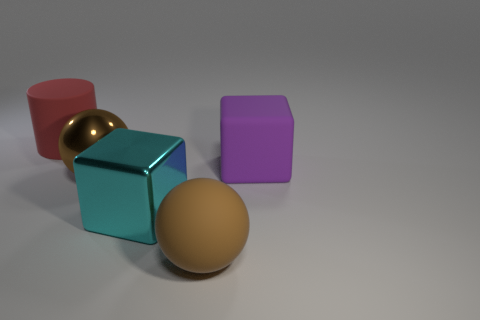Subtract all cyan blocks. How many blocks are left? 1 Add 1 matte cylinders. How many objects exist? 6 Subtract all blocks. How many objects are left? 3 Add 4 large brown metal objects. How many large brown metal objects are left? 5 Add 1 cyan spheres. How many cyan spheres exist? 1 Subtract 0 gray cylinders. How many objects are left? 5 Subtract 1 blocks. How many blocks are left? 1 Subtract all purple blocks. Subtract all cyan balls. How many blocks are left? 1 Subtract all large cyan metal things. Subtract all blocks. How many objects are left? 2 